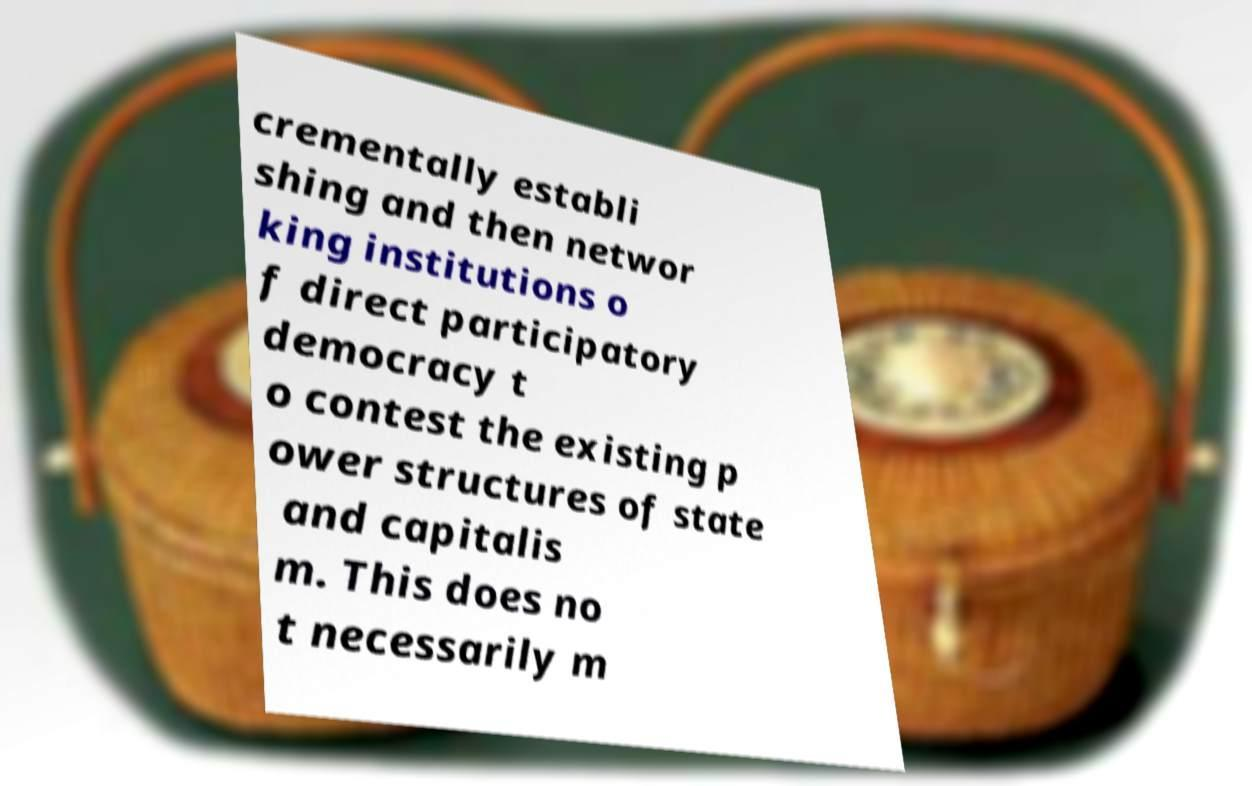What messages or text are displayed in this image? I need them in a readable, typed format. crementally establi shing and then networ king institutions o f direct participatory democracy t o contest the existing p ower structures of state and capitalis m. This does no t necessarily m 